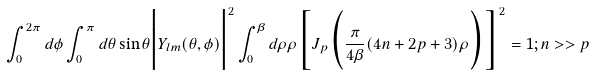<formula> <loc_0><loc_0><loc_500><loc_500>\int _ { 0 } ^ { 2 \pi } d \phi \int _ { 0 } ^ { \pi } d \theta \sin \theta \Big { | } Y _ { l m } ( \theta , \phi ) \Big { | } ^ { 2 } \int _ { 0 } ^ { \beta } d \rho \rho \Big { [ } J _ { p } \Big { ( } \frac { \pi } { 4 \beta } ( 4 n + 2 p + 3 ) \rho \Big { ) } \Big { ] } ^ { 2 } = 1 ; n > > p</formula> 